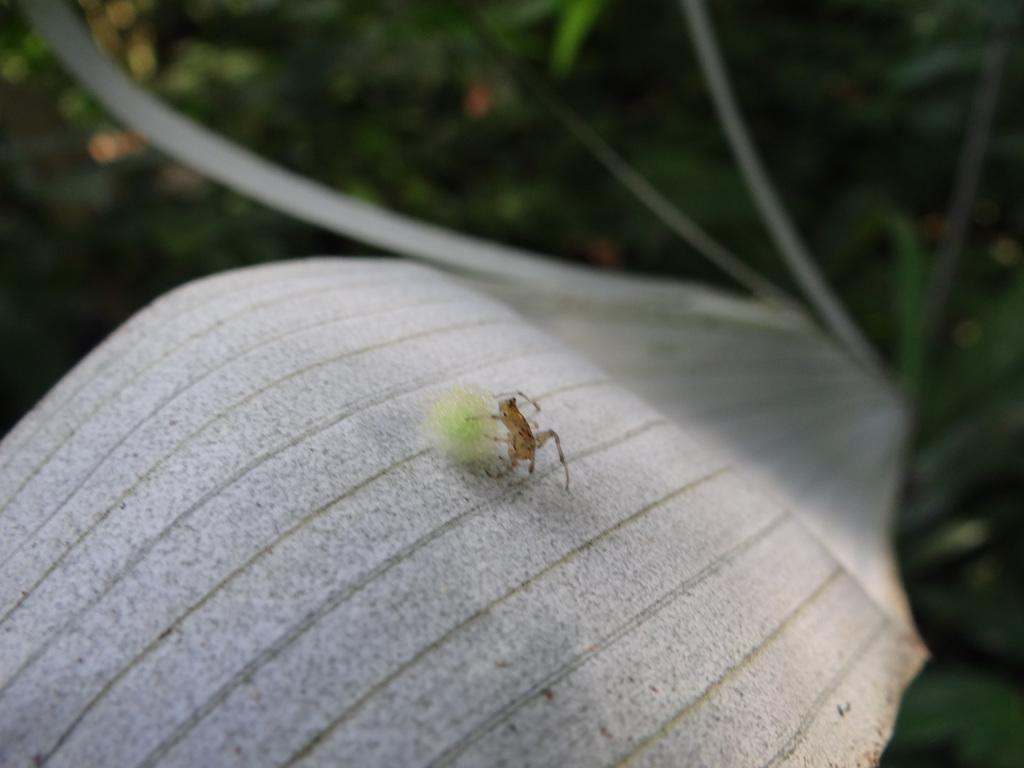What is present in the image? There is an insect in the image. Where is the insect located? The insect is on a leaf. What is the leaf a part of? The leaf belongs to a plant. How is the insect positioned in the image? The insect is in the middle of the image. What type of can does the insect use to drink water in the image? There is no can present in the image, and insects do not use cans to drink water. 